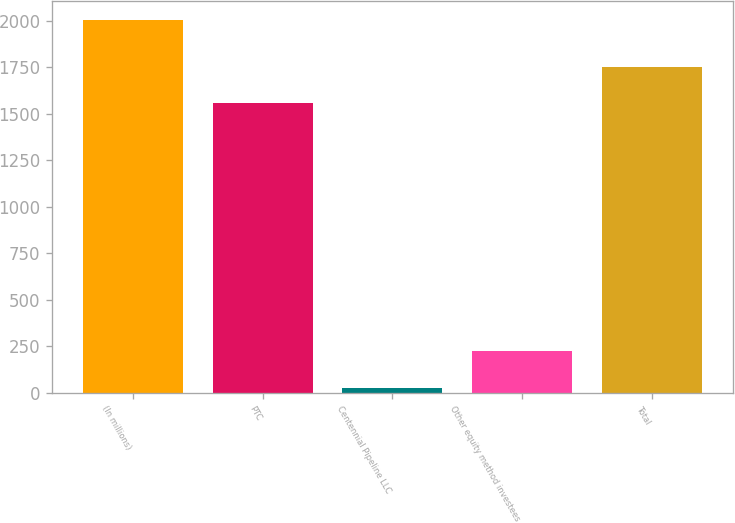<chart> <loc_0><loc_0><loc_500><loc_500><bar_chart><fcel>(In millions)<fcel>PTC<fcel>Centennial Pipeline LLC<fcel>Other equity method investees<fcel>Total<nl><fcel>2007<fcel>1556<fcel>27<fcel>225<fcel>1754<nl></chart> 